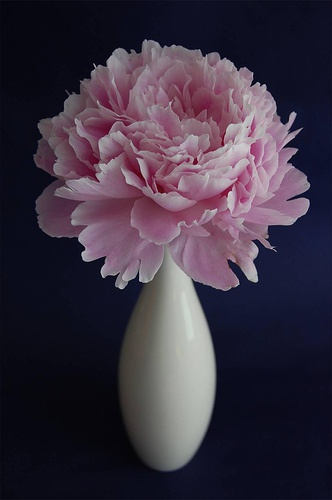Describe the objects in this image and their specific colors. I can see a vase in black, darkgray, gray, and lightgray tones in this image. 